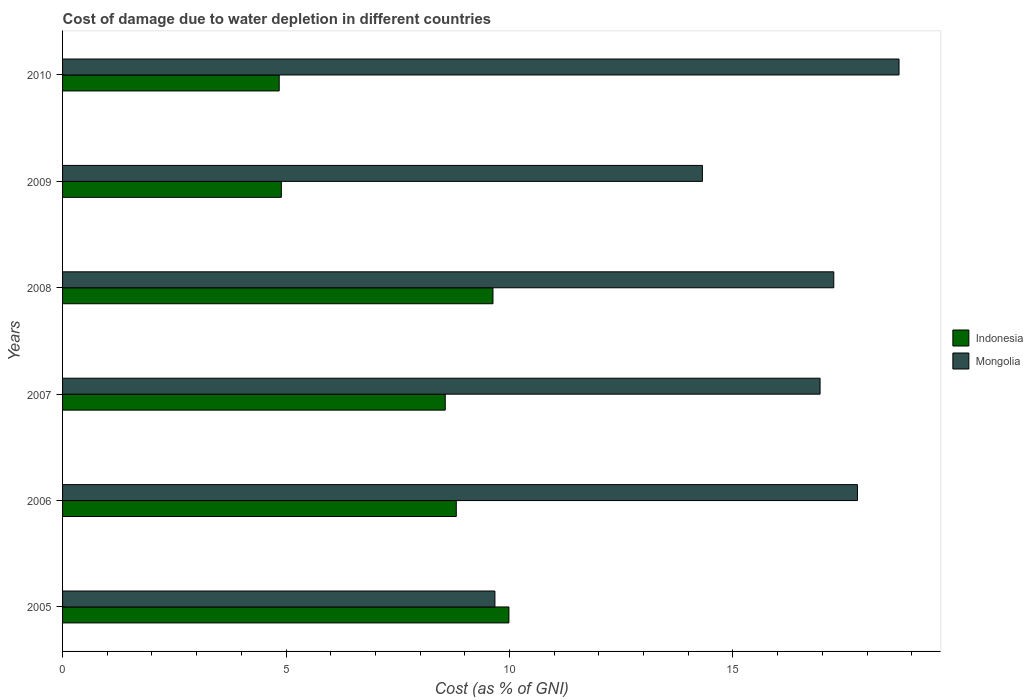How many different coloured bars are there?
Offer a terse response. 2. Are the number of bars per tick equal to the number of legend labels?
Make the answer very short. Yes. Are the number of bars on each tick of the Y-axis equal?
Keep it short and to the point. Yes. How many bars are there on the 6th tick from the bottom?
Keep it short and to the point. 2. In how many cases, is the number of bars for a given year not equal to the number of legend labels?
Offer a very short reply. 0. What is the cost of damage caused due to water depletion in Mongolia in 2007?
Ensure brevity in your answer.  16.95. Across all years, what is the maximum cost of damage caused due to water depletion in Indonesia?
Provide a short and direct response. 9.99. Across all years, what is the minimum cost of damage caused due to water depletion in Mongolia?
Provide a short and direct response. 9.67. In which year was the cost of damage caused due to water depletion in Mongolia maximum?
Offer a very short reply. 2010. In which year was the cost of damage caused due to water depletion in Mongolia minimum?
Offer a terse response. 2005. What is the total cost of damage caused due to water depletion in Indonesia in the graph?
Your response must be concise. 46.73. What is the difference between the cost of damage caused due to water depletion in Indonesia in 2007 and that in 2010?
Ensure brevity in your answer.  3.72. What is the difference between the cost of damage caused due to water depletion in Indonesia in 2006 and the cost of damage caused due to water depletion in Mongolia in 2007?
Your response must be concise. -8.14. What is the average cost of damage caused due to water depletion in Mongolia per year?
Give a very brief answer. 15.78. In the year 2007, what is the difference between the cost of damage caused due to water depletion in Mongolia and cost of damage caused due to water depletion in Indonesia?
Offer a terse response. 8.39. In how many years, is the cost of damage caused due to water depletion in Indonesia greater than 17 %?
Your answer should be compact. 0. What is the ratio of the cost of damage caused due to water depletion in Mongolia in 2009 to that in 2010?
Offer a terse response. 0.76. Is the cost of damage caused due to water depletion in Indonesia in 2005 less than that in 2010?
Your response must be concise. No. What is the difference between the highest and the second highest cost of damage caused due to water depletion in Mongolia?
Offer a very short reply. 0.93. What is the difference between the highest and the lowest cost of damage caused due to water depletion in Indonesia?
Offer a terse response. 5.14. Is the sum of the cost of damage caused due to water depletion in Mongolia in 2008 and 2010 greater than the maximum cost of damage caused due to water depletion in Indonesia across all years?
Keep it short and to the point. Yes. What does the 2nd bar from the bottom in 2007 represents?
Keep it short and to the point. Mongolia. How many bars are there?
Your answer should be compact. 12. What is the difference between two consecutive major ticks on the X-axis?
Offer a very short reply. 5. Are the values on the major ticks of X-axis written in scientific E-notation?
Offer a terse response. No. Does the graph contain any zero values?
Your answer should be very brief. No. Does the graph contain grids?
Provide a short and direct response. No. How many legend labels are there?
Offer a terse response. 2. How are the legend labels stacked?
Your response must be concise. Vertical. What is the title of the graph?
Offer a very short reply. Cost of damage due to water depletion in different countries. What is the label or title of the X-axis?
Your answer should be very brief. Cost (as % of GNI). What is the label or title of the Y-axis?
Offer a terse response. Years. What is the Cost (as % of GNI) in Indonesia in 2005?
Your answer should be compact. 9.99. What is the Cost (as % of GNI) in Mongolia in 2005?
Make the answer very short. 9.67. What is the Cost (as % of GNI) of Indonesia in 2006?
Provide a short and direct response. 8.81. What is the Cost (as % of GNI) of Mongolia in 2006?
Keep it short and to the point. 17.79. What is the Cost (as % of GNI) in Indonesia in 2007?
Your response must be concise. 8.56. What is the Cost (as % of GNI) in Mongolia in 2007?
Provide a short and direct response. 16.95. What is the Cost (as % of GNI) of Indonesia in 2008?
Give a very brief answer. 9.63. What is the Cost (as % of GNI) of Mongolia in 2008?
Make the answer very short. 17.26. What is the Cost (as % of GNI) of Indonesia in 2009?
Offer a very short reply. 4.9. What is the Cost (as % of GNI) in Mongolia in 2009?
Ensure brevity in your answer.  14.32. What is the Cost (as % of GNI) in Indonesia in 2010?
Offer a terse response. 4.85. What is the Cost (as % of GNI) of Mongolia in 2010?
Offer a very short reply. 18.72. Across all years, what is the maximum Cost (as % of GNI) in Indonesia?
Provide a succinct answer. 9.99. Across all years, what is the maximum Cost (as % of GNI) of Mongolia?
Offer a terse response. 18.72. Across all years, what is the minimum Cost (as % of GNI) in Indonesia?
Offer a terse response. 4.85. Across all years, what is the minimum Cost (as % of GNI) in Mongolia?
Give a very brief answer. 9.67. What is the total Cost (as % of GNI) in Indonesia in the graph?
Offer a terse response. 46.73. What is the total Cost (as % of GNI) in Mongolia in the graph?
Offer a very short reply. 94.69. What is the difference between the Cost (as % of GNI) in Indonesia in 2005 and that in 2006?
Ensure brevity in your answer.  1.18. What is the difference between the Cost (as % of GNI) in Mongolia in 2005 and that in 2006?
Your answer should be compact. -8.11. What is the difference between the Cost (as % of GNI) of Indonesia in 2005 and that in 2007?
Offer a very short reply. 1.42. What is the difference between the Cost (as % of GNI) of Mongolia in 2005 and that in 2007?
Make the answer very short. -7.27. What is the difference between the Cost (as % of GNI) of Indonesia in 2005 and that in 2008?
Your answer should be compact. 0.36. What is the difference between the Cost (as % of GNI) in Mongolia in 2005 and that in 2008?
Your answer should be very brief. -7.58. What is the difference between the Cost (as % of GNI) of Indonesia in 2005 and that in 2009?
Make the answer very short. 5.09. What is the difference between the Cost (as % of GNI) in Mongolia in 2005 and that in 2009?
Your answer should be very brief. -4.64. What is the difference between the Cost (as % of GNI) of Indonesia in 2005 and that in 2010?
Give a very brief answer. 5.14. What is the difference between the Cost (as % of GNI) in Mongolia in 2005 and that in 2010?
Your response must be concise. -9.04. What is the difference between the Cost (as % of GNI) of Indonesia in 2006 and that in 2007?
Provide a succinct answer. 0.25. What is the difference between the Cost (as % of GNI) of Mongolia in 2006 and that in 2007?
Provide a succinct answer. 0.84. What is the difference between the Cost (as % of GNI) in Indonesia in 2006 and that in 2008?
Your answer should be very brief. -0.82. What is the difference between the Cost (as % of GNI) in Mongolia in 2006 and that in 2008?
Provide a succinct answer. 0.53. What is the difference between the Cost (as % of GNI) in Indonesia in 2006 and that in 2009?
Make the answer very short. 3.91. What is the difference between the Cost (as % of GNI) of Mongolia in 2006 and that in 2009?
Give a very brief answer. 3.47. What is the difference between the Cost (as % of GNI) of Indonesia in 2006 and that in 2010?
Offer a very short reply. 3.96. What is the difference between the Cost (as % of GNI) of Mongolia in 2006 and that in 2010?
Ensure brevity in your answer.  -0.93. What is the difference between the Cost (as % of GNI) of Indonesia in 2007 and that in 2008?
Your response must be concise. -1.07. What is the difference between the Cost (as % of GNI) of Mongolia in 2007 and that in 2008?
Your answer should be compact. -0.31. What is the difference between the Cost (as % of GNI) in Indonesia in 2007 and that in 2009?
Provide a short and direct response. 3.67. What is the difference between the Cost (as % of GNI) of Mongolia in 2007 and that in 2009?
Ensure brevity in your answer.  2.63. What is the difference between the Cost (as % of GNI) of Indonesia in 2007 and that in 2010?
Offer a terse response. 3.71. What is the difference between the Cost (as % of GNI) in Mongolia in 2007 and that in 2010?
Your response must be concise. -1.77. What is the difference between the Cost (as % of GNI) of Indonesia in 2008 and that in 2009?
Give a very brief answer. 4.73. What is the difference between the Cost (as % of GNI) of Mongolia in 2008 and that in 2009?
Keep it short and to the point. 2.94. What is the difference between the Cost (as % of GNI) in Indonesia in 2008 and that in 2010?
Make the answer very short. 4.78. What is the difference between the Cost (as % of GNI) in Mongolia in 2008 and that in 2010?
Give a very brief answer. -1.46. What is the difference between the Cost (as % of GNI) of Indonesia in 2009 and that in 2010?
Your response must be concise. 0.05. What is the difference between the Cost (as % of GNI) in Mongolia in 2009 and that in 2010?
Offer a terse response. -4.4. What is the difference between the Cost (as % of GNI) in Indonesia in 2005 and the Cost (as % of GNI) in Mongolia in 2006?
Your response must be concise. -7.8. What is the difference between the Cost (as % of GNI) in Indonesia in 2005 and the Cost (as % of GNI) in Mongolia in 2007?
Ensure brevity in your answer.  -6.96. What is the difference between the Cost (as % of GNI) in Indonesia in 2005 and the Cost (as % of GNI) in Mongolia in 2008?
Provide a succinct answer. -7.27. What is the difference between the Cost (as % of GNI) in Indonesia in 2005 and the Cost (as % of GNI) in Mongolia in 2009?
Provide a short and direct response. -4.33. What is the difference between the Cost (as % of GNI) in Indonesia in 2005 and the Cost (as % of GNI) in Mongolia in 2010?
Keep it short and to the point. -8.73. What is the difference between the Cost (as % of GNI) in Indonesia in 2006 and the Cost (as % of GNI) in Mongolia in 2007?
Make the answer very short. -8.14. What is the difference between the Cost (as % of GNI) of Indonesia in 2006 and the Cost (as % of GNI) of Mongolia in 2008?
Provide a succinct answer. -8.45. What is the difference between the Cost (as % of GNI) of Indonesia in 2006 and the Cost (as % of GNI) of Mongolia in 2009?
Give a very brief answer. -5.51. What is the difference between the Cost (as % of GNI) in Indonesia in 2006 and the Cost (as % of GNI) in Mongolia in 2010?
Your response must be concise. -9.91. What is the difference between the Cost (as % of GNI) in Indonesia in 2007 and the Cost (as % of GNI) in Mongolia in 2008?
Your answer should be compact. -8.69. What is the difference between the Cost (as % of GNI) of Indonesia in 2007 and the Cost (as % of GNI) of Mongolia in 2009?
Provide a short and direct response. -5.75. What is the difference between the Cost (as % of GNI) of Indonesia in 2007 and the Cost (as % of GNI) of Mongolia in 2010?
Give a very brief answer. -10.15. What is the difference between the Cost (as % of GNI) in Indonesia in 2008 and the Cost (as % of GNI) in Mongolia in 2009?
Make the answer very short. -4.69. What is the difference between the Cost (as % of GNI) of Indonesia in 2008 and the Cost (as % of GNI) of Mongolia in 2010?
Your answer should be very brief. -9.09. What is the difference between the Cost (as % of GNI) in Indonesia in 2009 and the Cost (as % of GNI) in Mongolia in 2010?
Your response must be concise. -13.82. What is the average Cost (as % of GNI) in Indonesia per year?
Provide a succinct answer. 7.79. What is the average Cost (as % of GNI) of Mongolia per year?
Offer a very short reply. 15.78. In the year 2005, what is the difference between the Cost (as % of GNI) in Indonesia and Cost (as % of GNI) in Mongolia?
Give a very brief answer. 0.31. In the year 2006, what is the difference between the Cost (as % of GNI) in Indonesia and Cost (as % of GNI) in Mongolia?
Provide a succinct answer. -8.98. In the year 2007, what is the difference between the Cost (as % of GNI) in Indonesia and Cost (as % of GNI) in Mongolia?
Keep it short and to the point. -8.39. In the year 2008, what is the difference between the Cost (as % of GNI) in Indonesia and Cost (as % of GNI) in Mongolia?
Offer a very short reply. -7.63. In the year 2009, what is the difference between the Cost (as % of GNI) of Indonesia and Cost (as % of GNI) of Mongolia?
Provide a short and direct response. -9.42. In the year 2010, what is the difference between the Cost (as % of GNI) in Indonesia and Cost (as % of GNI) in Mongolia?
Keep it short and to the point. -13.87. What is the ratio of the Cost (as % of GNI) of Indonesia in 2005 to that in 2006?
Make the answer very short. 1.13. What is the ratio of the Cost (as % of GNI) in Mongolia in 2005 to that in 2006?
Your answer should be compact. 0.54. What is the ratio of the Cost (as % of GNI) in Indonesia in 2005 to that in 2007?
Give a very brief answer. 1.17. What is the ratio of the Cost (as % of GNI) in Mongolia in 2005 to that in 2007?
Offer a terse response. 0.57. What is the ratio of the Cost (as % of GNI) of Indonesia in 2005 to that in 2008?
Provide a short and direct response. 1.04. What is the ratio of the Cost (as % of GNI) of Mongolia in 2005 to that in 2008?
Provide a short and direct response. 0.56. What is the ratio of the Cost (as % of GNI) in Indonesia in 2005 to that in 2009?
Your response must be concise. 2.04. What is the ratio of the Cost (as % of GNI) in Mongolia in 2005 to that in 2009?
Provide a short and direct response. 0.68. What is the ratio of the Cost (as % of GNI) in Indonesia in 2005 to that in 2010?
Your answer should be compact. 2.06. What is the ratio of the Cost (as % of GNI) of Mongolia in 2005 to that in 2010?
Provide a short and direct response. 0.52. What is the ratio of the Cost (as % of GNI) in Indonesia in 2006 to that in 2007?
Give a very brief answer. 1.03. What is the ratio of the Cost (as % of GNI) in Mongolia in 2006 to that in 2007?
Offer a terse response. 1.05. What is the ratio of the Cost (as % of GNI) in Indonesia in 2006 to that in 2008?
Your answer should be very brief. 0.91. What is the ratio of the Cost (as % of GNI) of Mongolia in 2006 to that in 2008?
Keep it short and to the point. 1.03. What is the ratio of the Cost (as % of GNI) in Indonesia in 2006 to that in 2009?
Make the answer very short. 1.8. What is the ratio of the Cost (as % of GNI) of Mongolia in 2006 to that in 2009?
Provide a short and direct response. 1.24. What is the ratio of the Cost (as % of GNI) in Indonesia in 2006 to that in 2010?
Offer a very short reply. 1.82. What is the ratio of the Cost (as % of GNI) of Mongolia in 2006 to that in 2010?
Give a very brief answer. 0.95. What is the ratio of the Cost (as % of GNI) of Indonesia in 2007 to that in 2008?
Give a very brief answer. 0.89. What is the ratio of the Cost (as % of GNI) in Mongolia in 2007 to that in 2008?
Your response must be concise. 0.98. What is the ratio of the Cost (as % of GNI) of Indonesia in 2007 to that in 2009?
Give a very brief answer. 1.75. What is the ratio of the Cost (as % of GNI) of Mongolia in 2007 to that in 2009?
Ensure brevity in your answer.  1.18. What is the ratio of the Cost (as % of GNI) of Indonesia in 2007 to that in 2010?
Provide a short and direct response. 1.77. What is the ratio of the Cost (as % of GNI) in Mongolia in 2007 to that in 2010?
Your answer should be compact. 0.91. What is the ratio of the Cost (as % of GNI) in Indonesia in 2008 to that in 2009?
Your response must be concise. 1.97. What is the ratio of the Cost (as % of GNI) in Mongolia in 2008 to that in 2009?
Provide a succinct answer. 1.21. What is the ratio of the Cost (as % of GNI) of Indonesia in 2008 to that in 2010?
Keep it short and to the point. 1.99. What is the ratio of the Cost (as % of GNI) of Mongolia in 2008 to that in 2010?
Provide a short and direct response. 0.92. What is the ratio of the Cost (as % of GNI) of Indonesia in 2009 to that in 2010?
Your answer should be compact. 1.01. What is the ratio of the Cost (as % of GNI) in Mongolia in 2009 to that in 2010?
Give a very brief answer. 0.76. What is the difference between the highest and the second highest Cost (as % of GNI) in Indonesia?
Provide a succinct answer. 0.36. What is the difference between the highest and the second highest Cost (as % of GNI) in Mongolia?
Make the answer very short. 0.93. What is the difference between the highest and the lowest Cost (as % of GNI) in Indonesia?
Provide a short and direct response. 5.14. What is the difference between the highest and the lowest Cost (as % of GNI) in Mongolia?
Ensure brevity in your answer.  9.04. 